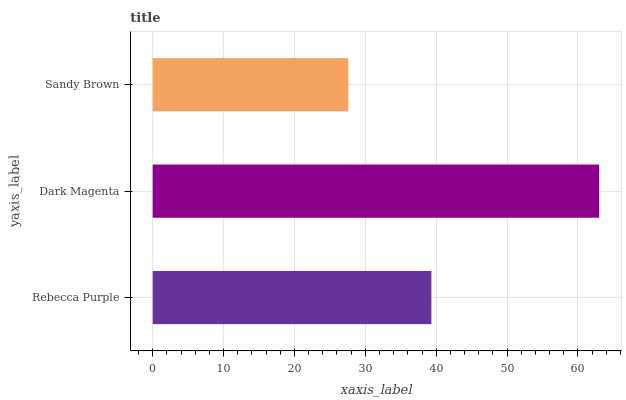Is Sandy Brown the minimum?
Answer yes or no. Yes. Is Dark Magenta the maximum?
Answer yes or no. Yes. Is Dark Magenta the minimum?
Answer yes or no. No. Is Sandy Brown the maximum?
Answer yes or no. No. Is Dark Magenta greater than Sandy Brown?
Answer yes or no. Yes. Is Sandy Brown less than Dark Magenta?
Answer yes or no. Yes. Is Sandy Brown greater than Dark Magenta?
Answer yes or no. No. Is Dark Magenta less than Sandy Brown?
Answer yes or no. No. Is Rebecca Purple the high median?
Answer yes or no. Yes. Is Rebecca Purple the low median?
Answer yes or no. Yes. Is Sandy Brown the high median?
Answer yes or no. No. Is Dark Magenta the low median?
Answer yes or no. No. 